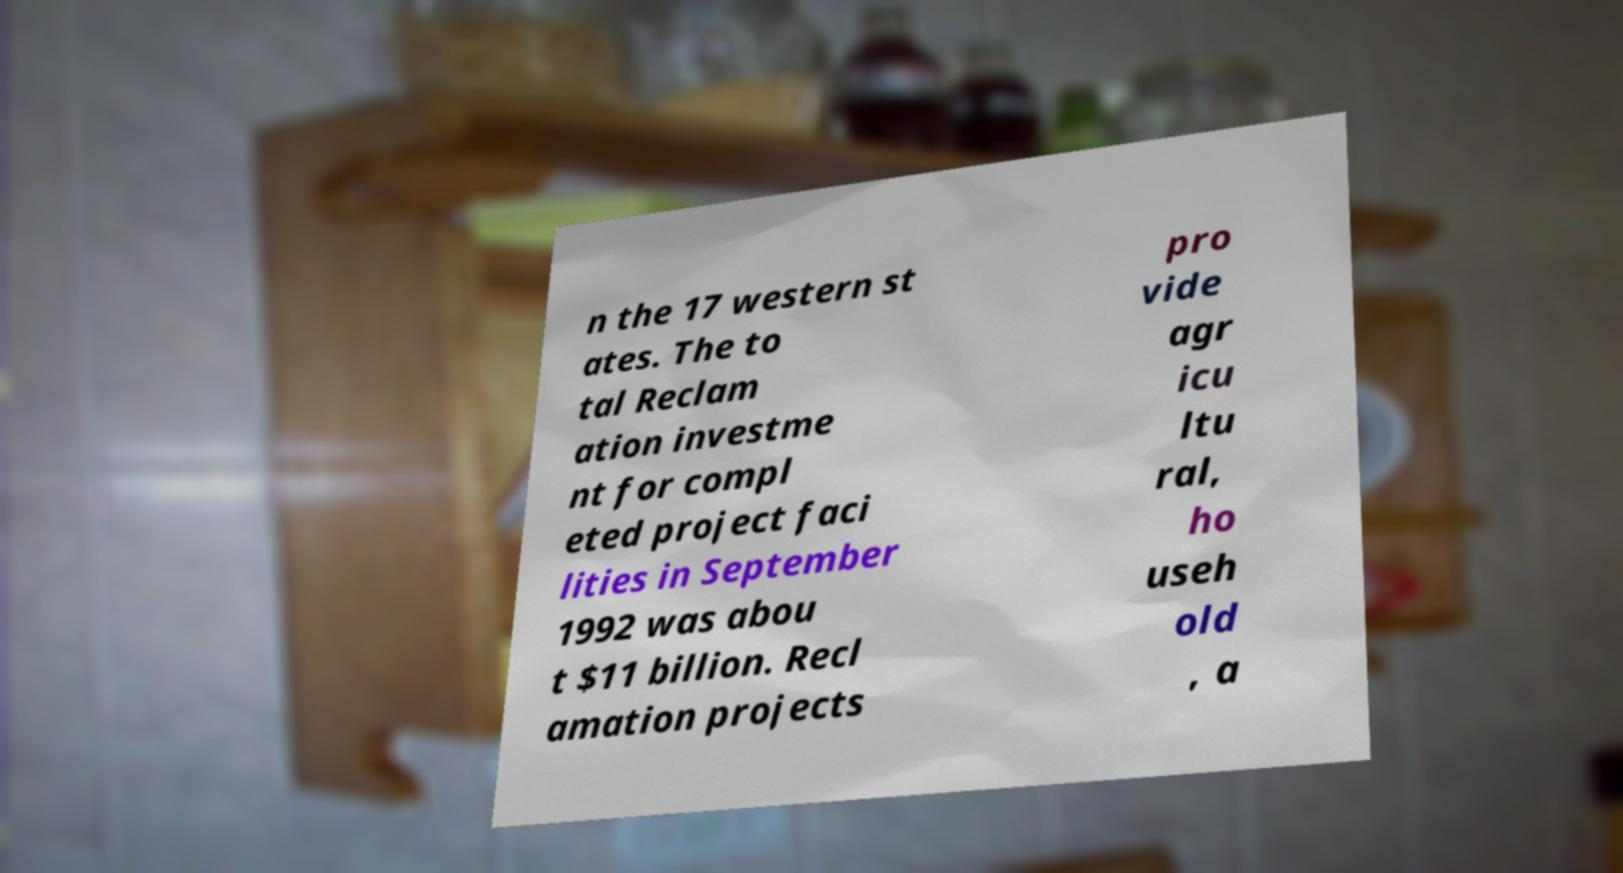For documentation purposes, I need the text within this image transcribed. Could you provide that? n the 17 western st ates. The to tal Reclam ation investme nt for compl eted project faci lities in September 1992 was abou t $11 billion. Recl amation projects pro vide agr icu ltu ral, ho useh old , a 